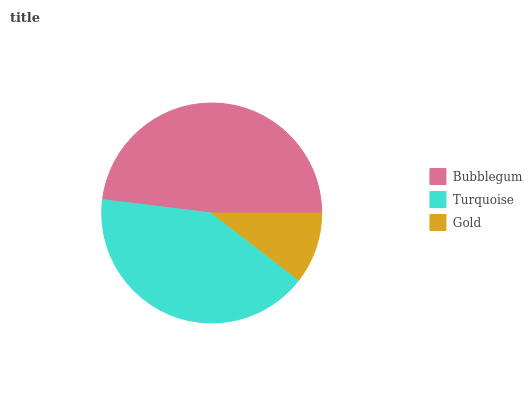Is Gold the minimum?
Answer yes or no. Yes. Is Bubblegum the maximum?
Answer yes or no. Yes. Is Turquoise the minimum?
Answer yes or no. No. Is Turquoise the maximum?
Answer yes or no. No. Is Bubblegum greater than Turquoise?
Answer yes or no. Yes. Is Turquoise less than Bubblegum?
Answer yes or no. Yes. Is Turquoise greater than Bubblegum?
Answer yes or no. No. Is Bubblegum less than Turquoise?
Answer yes or no. No. Is Turquoise the high median?
Answer yes or no. Yes. Is Turquoise the low median?
Answer yes or no. Yes. Is Bubblegum the high median?
Answer yes or no. No. Is Bubblegum the low median?
Answer yes or no. No. 